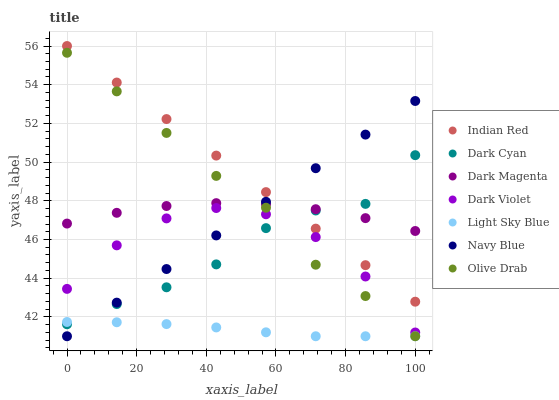Does Light Sky Blue have the minimum area under the curve?
Answer yes or no. Yes. Does Indian Red have the maximum area under the curve?
Answer yes or no. Yes. Does Navy Blue have the minimum area under the curve?
Answer yes or no. No. Does Navy Blue have the maximum area under the curve?
Answer yes or no. No. Is Indian Red the smoothest?
Answer yes or no. Yes. Is Dark Violet the roughest?
Answer yes or no. Yes. Is Navy Blue the smoothest?
Answer yes or no. No. Is Navy Blue the roughest?
Answer yes or no. No. Does Navy Blue have the lowest value?
Answer yes or no. Yes. Does Dark Violet have the lowest value?
Answer yes or no. No. Does Indian Red have the highest value?
Answer yes or no. Yes. Does Navy Blue have the highest value?
Answer yes or no. No. Is Dark Violet less than Indian Red?
Answer yes or no. Yes. Is Indian Red greater than Olive Drab?
Answer yes or no. Yes. Does Dark Magenta intersect Olive Drab?
Answer yes or no. Yes. Is Dark Magenta less than Olive Drab?
Answer yes or no. No. Is Dark Magenta greater than Olive Drab?
Answer yes or no. No. Does Dark Violet intersect Indian Red?
Answer yes or no. No. 